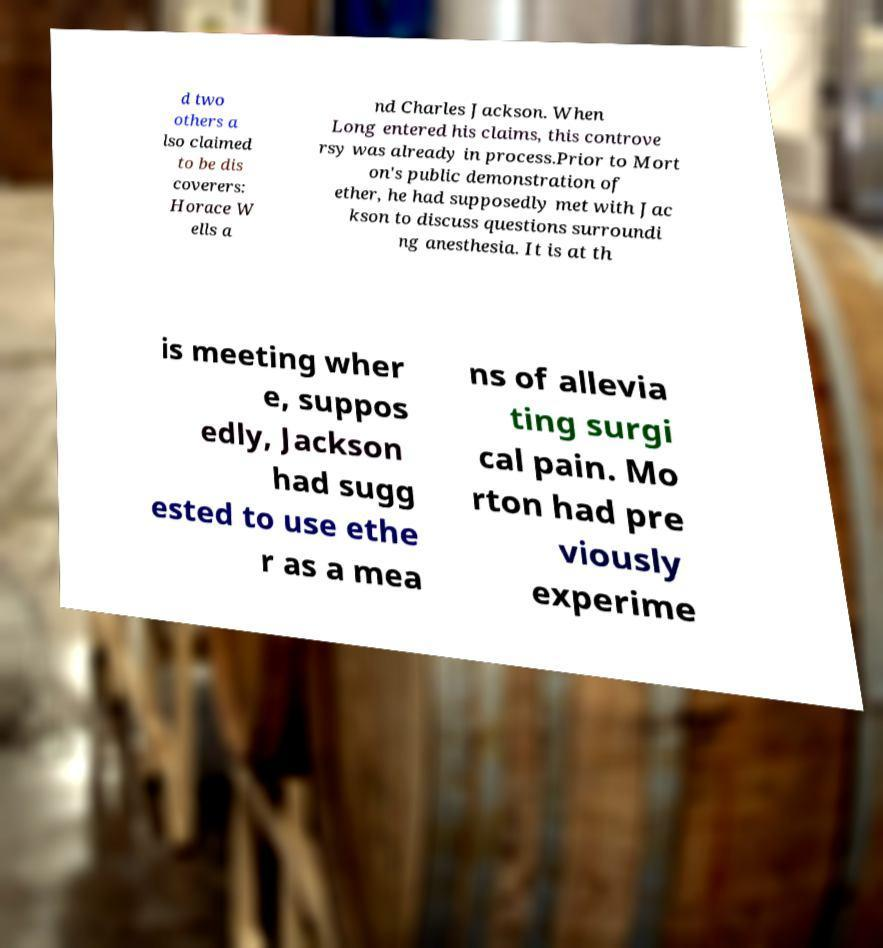Could you assist in decoding the text presented in this image and type it out clearly? d two others a lso claimed to be dis coverers: Horace W ells a nd Charles Jackson. When Long entered his claims, this controve rsy was already in process.Prior to Mort on's public demonstration of ether, he had supposedly met with Jac kson to discuss questions surroundi ng anesthesia. It is at th is meeting wher e, suppos edly, Jackson had sugg ested to use ethe r as a mea ns of allevia ting surgi cal pain. Mo rton had pre viously experime 